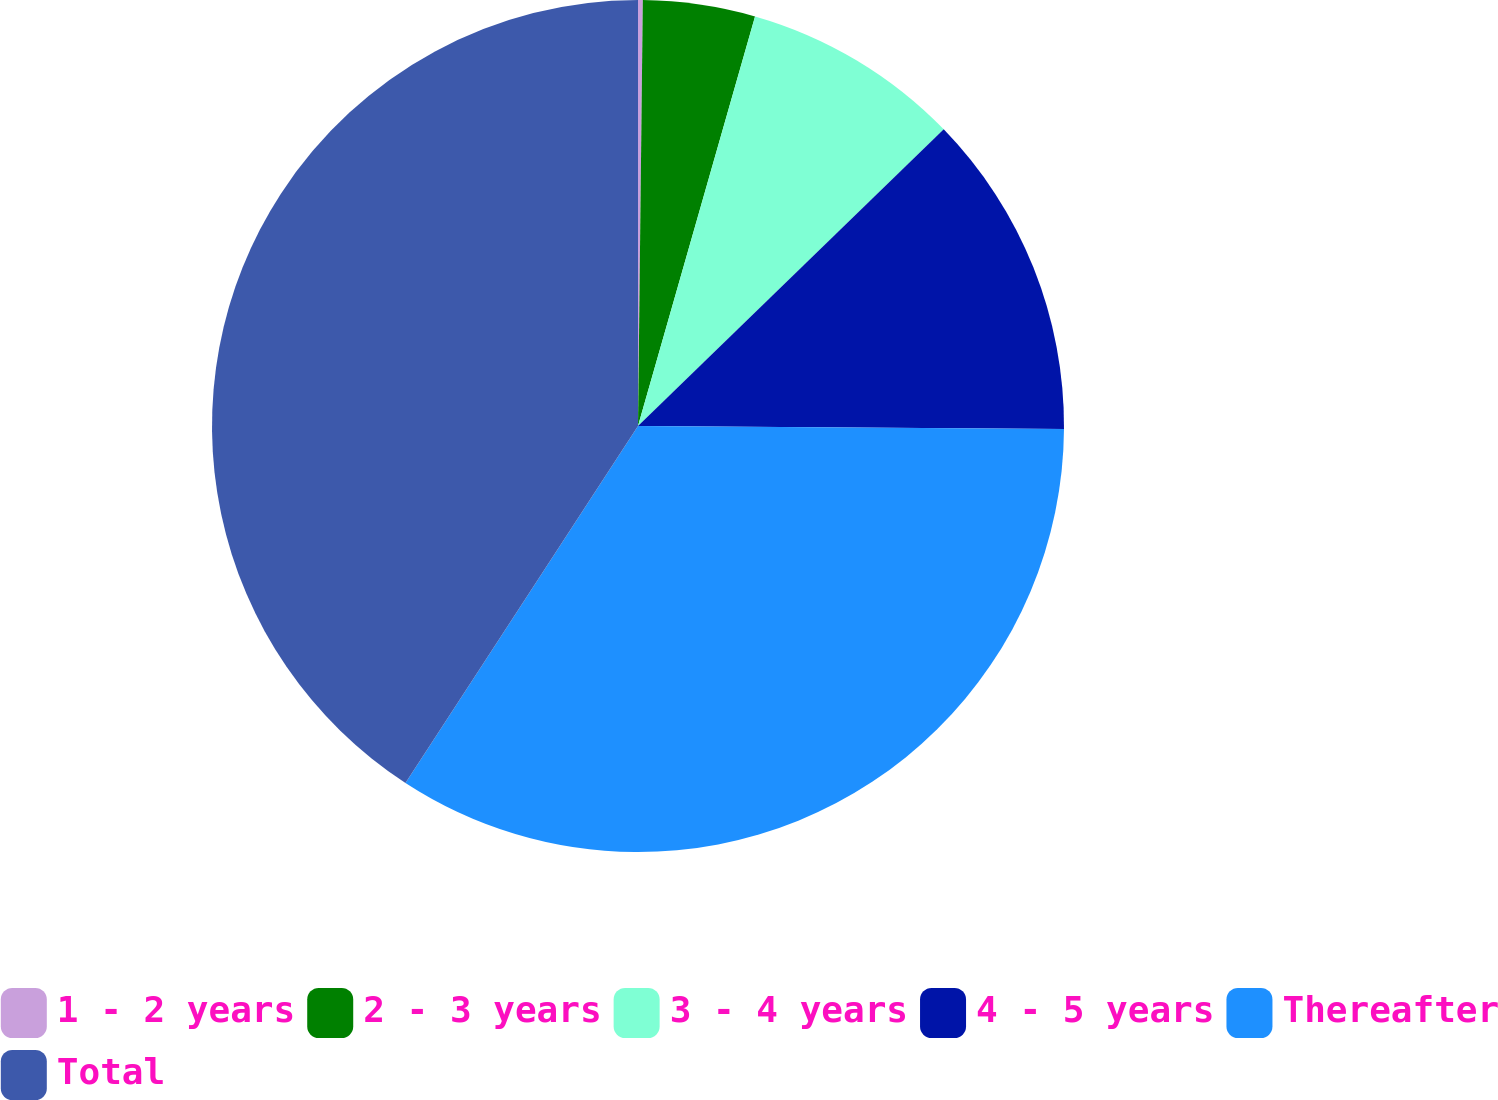Convert chart. <chart><loc_0><loc_0><loc_500><loc_500><pie_chart><fcel>1 - 2 years<fcel>2 - 3 years<fcel>3 - 4 years<fcel>4 - 5 years<fcel>Thereafter<fcel>Total<nl><fcel>0.18%<fcel>4.25%<fcel>8.31%<fcel>12.37%<fcel>34.08%<fcel>40.81%<nl></chart> 